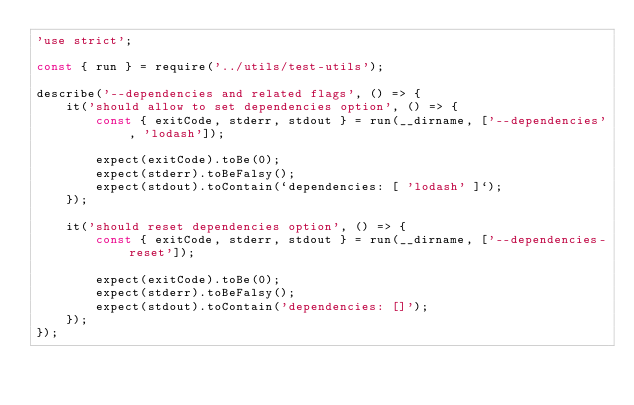Convert code to text. <code><loc_0><loc_0><loc_500><loc_500><_JavaScript_>'use strict';

const { run } = require('../utils/test-utils');

describe('--dependencies and related flags', () => {
    it('should allow to set dependencies option', () => {
        const { exitCode, stderr, stdout } = run(__dirname, ['--dependencies', 'lodash']);

        expect(exitCode).toBe(0);
        expect(stderr).toBeFalsy();
        expect(stdout).toContain(`dependencies: [ 'lodash' ]`);
    });

    it('should reset dependencies option', () => {
        const { exitCode, stderr, stdout } = run(__dirname, ['--dependencies-reset']);

        expect(exitCode).toBe(0);
        expect(stderr).toBeFalsy();
        expect(stdout).toContain('dependencies: []');
    });
});
</code> 